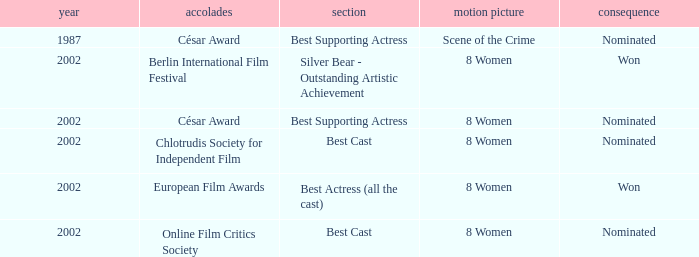What was the result at the Berlin International Film Festival in a year greater than 1987? Won. 